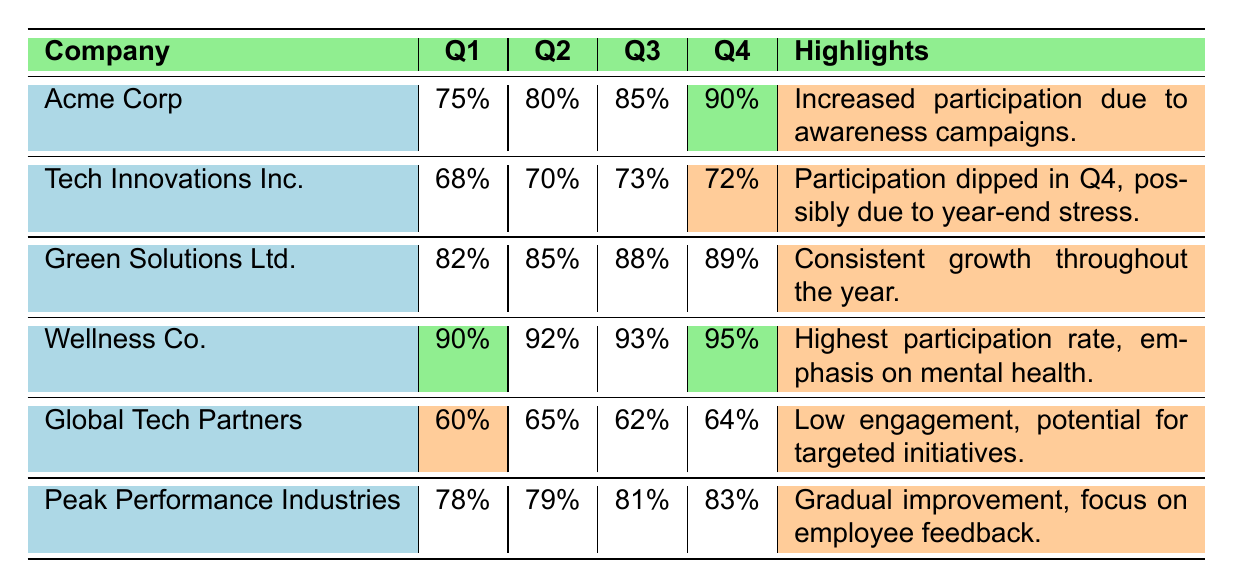What was the participation rate of Wellness Co. in Q4? The table shows that the participation rate for Wellness Co. in Q4 is highlighted as 95%, which indicates it is the highest participation rate for that quarter.
Answer: 95% Which company had the lowest participation rate in Q1? Looking at the Q1 participation rates, Global Tech Partners has 60%, which is the lowest compared to the other companies listed.
Answer: Global Tech Partners What was the average participation rate for Tech Innovations Inc. across all four quarters? To calculate the average, add the participation rates (68 + 70 + 73 + 72 = 283) and divide by the number of quarters (4). The average participation rate is 283 / 4 = 70.75%.
Answer: 70.75% Did Green Solutions Ltd. show consistent growth throughout the year? Yes, the participation rates for Green Solutions Ltd. are increasing each quarter (82%, 85%, 88%, 89%), confirming consistent growth.
Answer: Yes What was the difference in participation rates between Wellness Co. and Acme Corp in Q1? The participation rate for Wellness Co. in Q1 is 90%, and for Acme Corp, it is 75%. The difference is 90 - 75 = 15%.
Answer: 15% Which company experienced a dip in participation rates in Q4? Tech Innovations Inc.'s participation rate in Q4 is 72%, which is lower compared to previous quarters, indicating a dip.
Answer: Tech Innovations Inc If you combine the participation rates of Peak Performance Industries for Q2 and Q4, what would that total be? Peak Performance Industries had a participation rate of 79% in Q2 and 83% in Q4. Adding these together gives 79 + 83 = 162%.
Answer: 162% Which company's participation rate was the same for Q3 and Q4? Green Solutions Ltd. had a participation rate of 88% in Q3 and 89% in Q4, which means they did not have the same rate. The answer is therefore no other company fits this criterion.
Answer: No company What is the trend observed in the participation rates of Acme Corp? The rates are increasing every quarter as they go from 75% in Q1 to 90% in Q4, indicating a positive trend in participation.
Answer: Increasing What was the highest participation rate recorded for any company in Q3? The highest participation rate in Q3 was 93% from Wellness Co., which is the highest among all companies listed.
Answer: 93% 